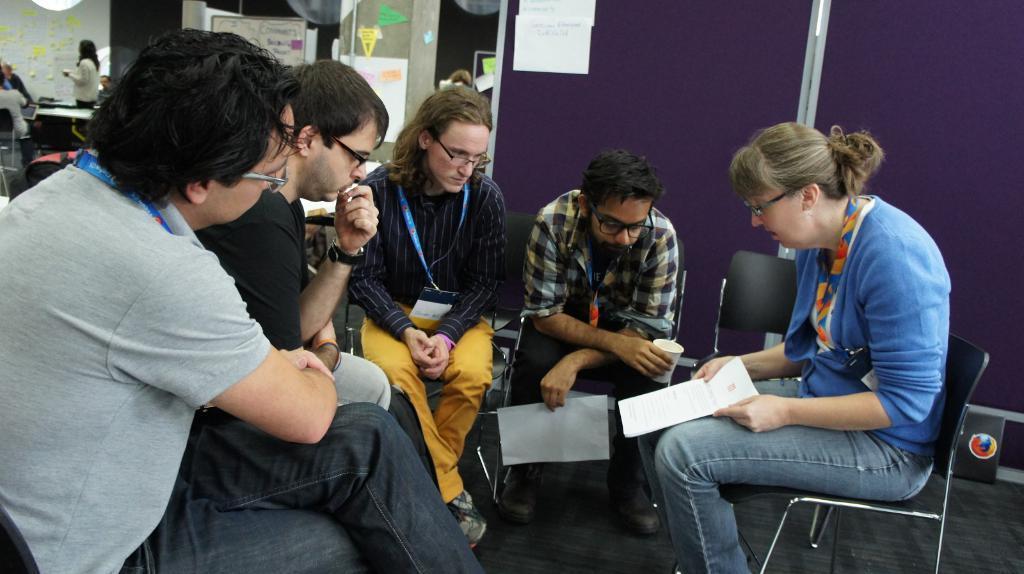How would you summarize this image in a sentence or two? In this picture we can see five people wore spectacles and sitting on chairs and a woman holding a paper with her hands and a man holding a glass, paper with his hands and in the background we can see posters, boards, some people and some objects. 